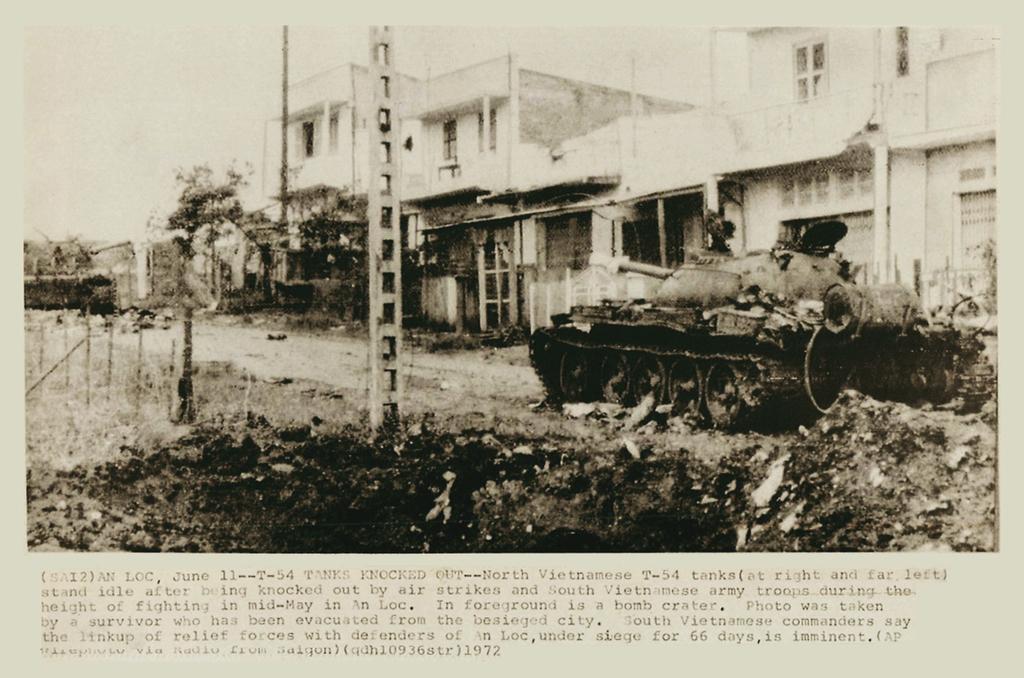How would you summarize this image in a sentence or two? This image consists of a paper in which there is a panzer along with the buildings. To the left, there are poles. At the bottom, there is a text. 